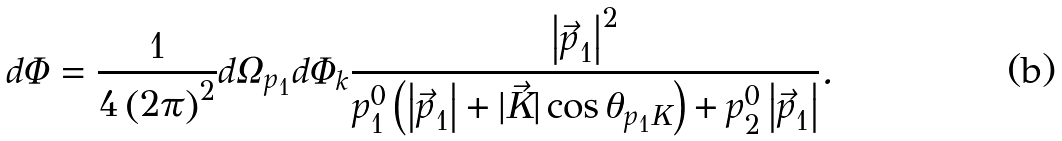<formula> <loc_0><loc_0><loc_500><loc_500>d \Phi = \frac { 1 } { 4 \left ( 2 \pi \right ) ^ { 2 } } d \Omega _ { p _ { 1 } } d \Phi _ { k } \frac { \left | \vec { p } _ { 1 } \right | ^ { 2 } } { p _ { 1 } ^ { 0 } \left ( \left | \vec { p } _ { 1 } \right | + \left | \vec { K } \right | \cos \theta _ { p _ { 1 } K } \right ) + p _ { 2 } ^ { 0 } \left | \vec { p } _ { 1 } \right | } .</formula> 